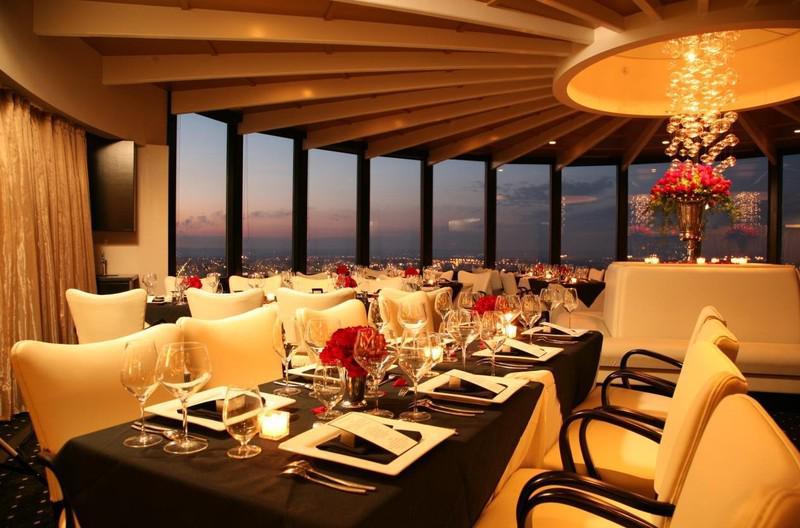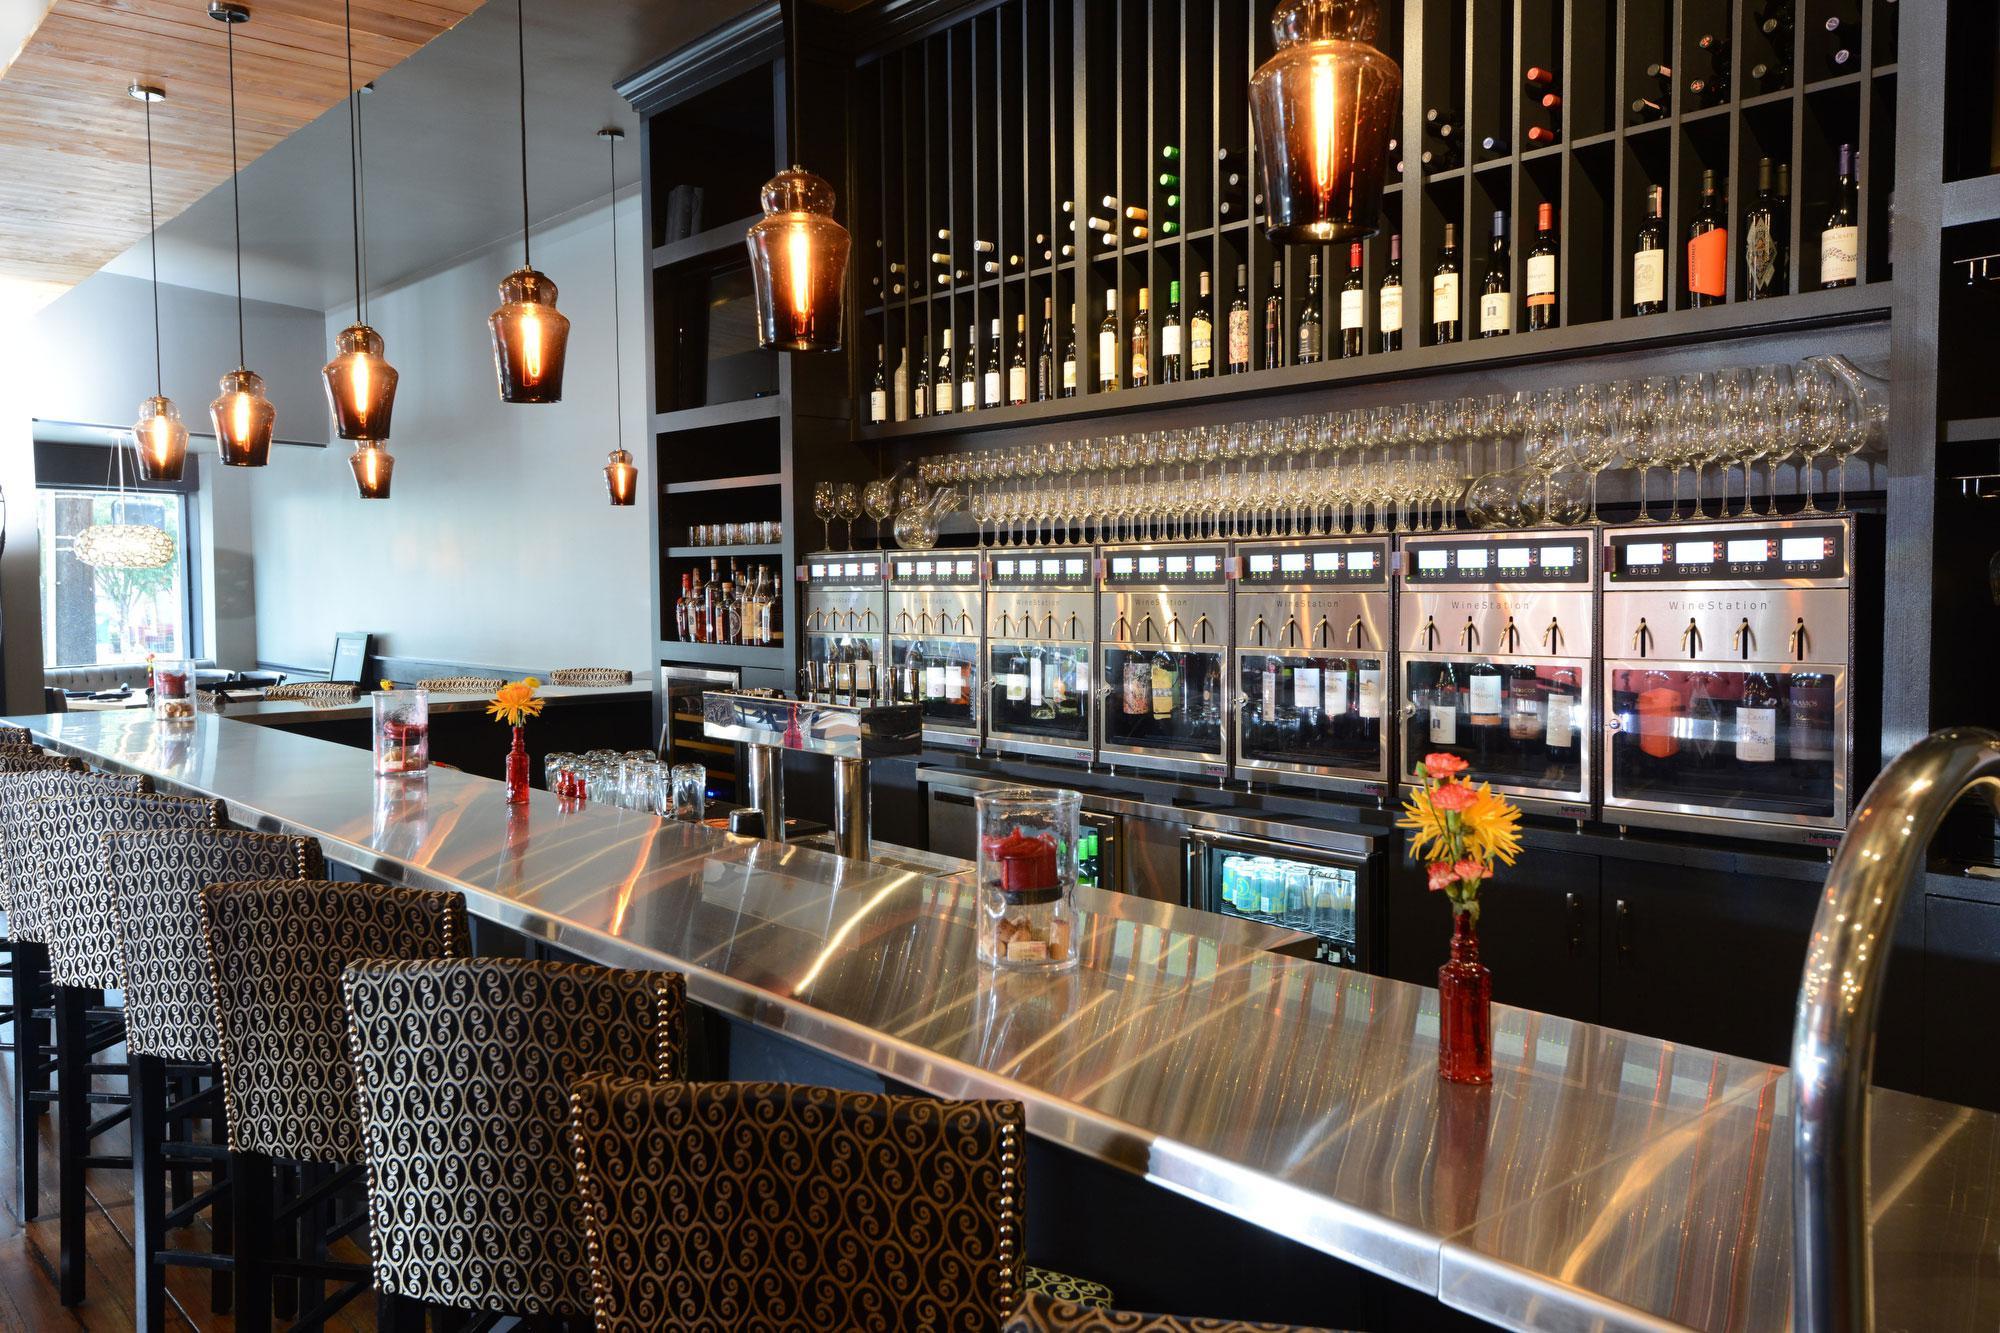The first image is the image on the left, the second image is the image on the right. Examine the images to the left and right. Is the description "The vacant dining tables have lit candles on them." accurate? Answer yes or no. Yes. The first image is the image on the left, the second image is the image on the right. For the images displayed, is the sentence "There ae six dropped lights hanging over the long bar." factually correct? Answer yes or no. Yes. 